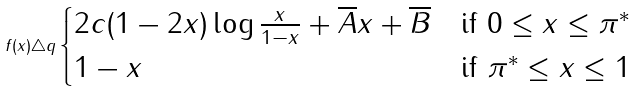Convert formula to latex. <formula><loc_0><loc_0><loc_500><loc_500>f ( x ) \triangle q \begin{cases} 2 c ( 1 - 2 x ) \log \frac { x } { 1 - x } + \overline { A } x + \overline { B } & \text {if } 0 \leq x \leq \pi ^ { * } \\ 1 - x & \text {if } \pi ^ { * } \leq x \leq 1 \end{cases}</formula> 